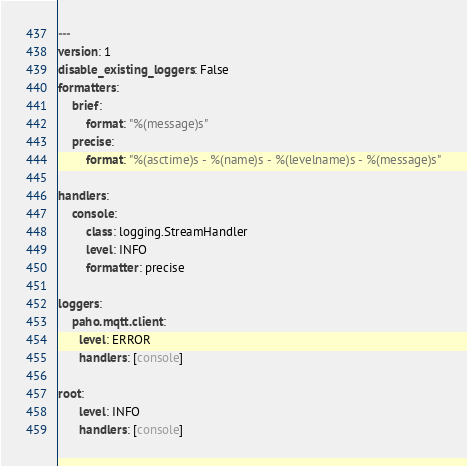<code> <loc_0><loc_0><loc_500><loc_500><_YAML_>---
version: 1
disable_existing_loggers: False
formatters:
    brief:
        format: "%(message)s"
    precise:
        format: "%(asctime)s - %(name)s - %(levelname)s - %(message)s"

handlers:
    console:
        class: logging.StreamHandler
        level: INFO
        formatter: precise

loggers:
    paho.mqtt.client:
      level: ERROR
      handlers: [console]

root:
      level: INFO
      handlers: [console]
</code> 